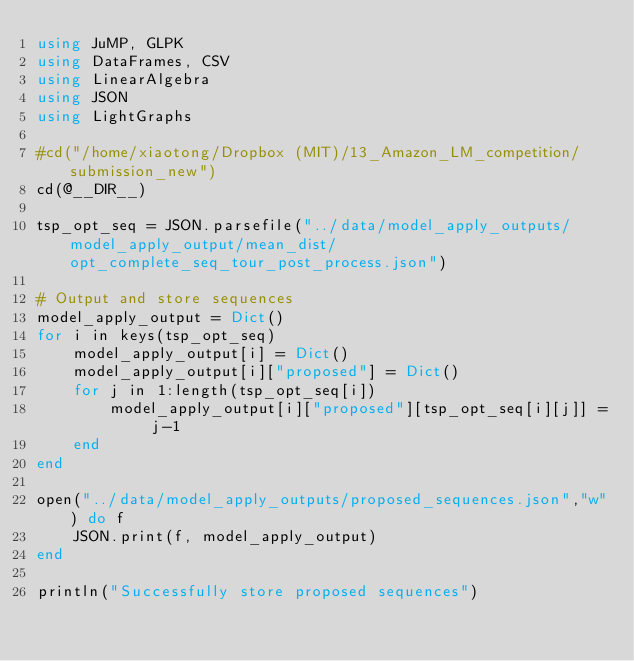Convert code to text. <code><loc_0><loc_0><loc_500><loc_500><_Julia_>using JuMP, GLPK
using DataFrames, CSV
using LinearAlgebra
using JSON
using LightGraphs

#cd("/home/xiaotong/Dropbox (MIT)/13_Amazon_LM_competition/submission_new")
cd(@__DIR__)

tsp_opt_seq = JSON.parsefile("../data/model_apply_outputs/model_apply_output/mean_dist/opt_complete_seq_tour_post_process.json")

# Output and store sequences
model_apply_output = Dict()
for i in keys(tsp_opt_seq)
    model_apply_output[i] = Dict()
    model_apply_output[i]["proposed"] = Dict()
    for j in 1:length(tsp_opt_seq[i])
        model_apply_output[i]["proposed"][tsp_opt_seq[i][j]] = j-1
    end
end

open("../data/model_apply_outputs/proposed_sequences.json","w") do f
    JSON.print(f, model_apply_output)
end

println("Successfully store proposed sequences")
</code> 